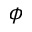<formula> <loc_0><loc_0><loc_500><loc_500>\phi</formula> 